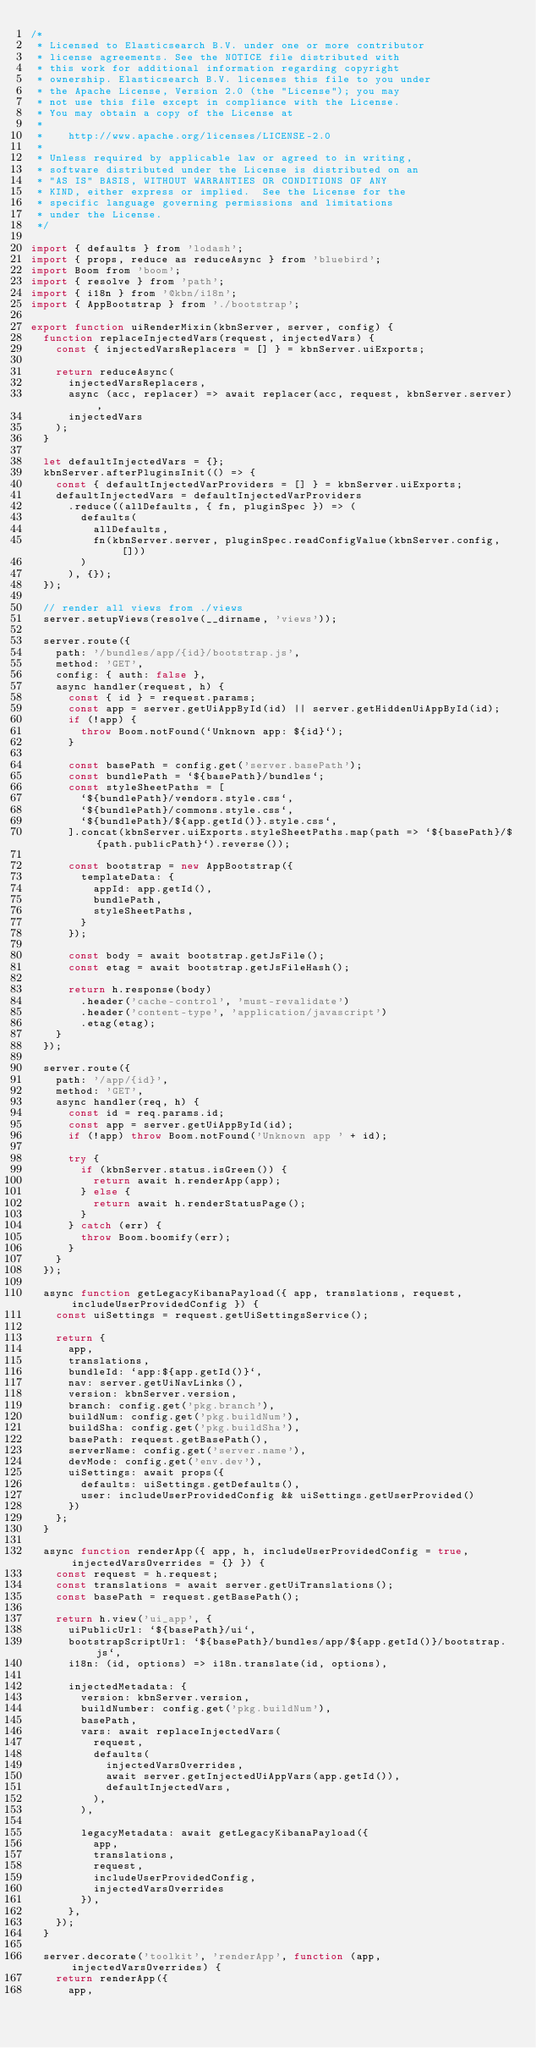Convert code to text. <code><loc_0><loc_0><loc_500><loc_500><_JavaScript_>/*
 * Licensed to Elasticsearch B.V. under one or more contributor
 * license agreements. See the NOTICE file distributed with
 * this work for additional information regarding copyright
 * ownership. Elasticsearch B.V. licenses this file to you under
 * the Apache License, Version 2.0 (the "License"); you may
 * not use this file except in compliance with the License.
 * You may obtain a copy of the License at
 *
 *    http://www.apache.org/licenses/LICENSE-2.0
 *
 * Unless required by applicable law or agreed to in writing,
 * software distributed under the License is distributed on an
 * "AS IS" BASIS, WITHOUT WARRANTIES OR CONDITIONS OF ANY
 * KIND, either express or implied.  See the License for the
 * specific language governing permissions and limitations
 * under the License.
 */

import { defaults } from 'lodash';
import { props, reduce as reduceAsync } from 'bluebird';
import Boom from 'boom';
import { resolve } from 'path';
import { i18n } from '@kbn/i18n';
import { AppBootstrap } from './bootstrap';

export function uiRenderMixin(kbnServer, server, config) {
  function replaceInjectedVars(request, injectedVars) {
    const { injectedVarsReplacers = [] } = kbnServer.uiExports;

    return reduceAsync(
      injectedVarsReplacers,
      async (acc, replacer) => await replacer(acc, request, kbnServer.server),
      injectedVars
    );
  }

  let defaultInjectedVars = {};
  kbnServer.afterPluginsInit(() => {
    const { defaultInjectedVarProviders = [] } = kbnServer.uiExports;
    defaultInjectedVars = defaultInjectedVarProviders
      .reduce((allDefaults, { fn, pluginSpec }) => (
        defaults(
          allDefaults,
          fn(kbnServer.server, pluginSpec.readConfigValue(kbnServer.config, []))
        )
      ), {});
  });

  // render all views from ./views
  server.setupViews(resolve(__dirname, 'views'));

  server.route({
    path: '/bundles/app/{id}/bootstrap.js',
    method: 'GET',
    config: { auth: false },
    async handler(request, h) {
      const { id } = request.params;
      const app = server.getUiAppById(id) || server.getHiddenUiAppById(id);
      if (!app) {
        throw Boom.notFound(`Unknown app: ${id}`);
      }

      const basePath = config.get('server.basePath');
      const bundlePath = `${basePath}/bundles`;
      const styleSheetPaths = [
        `${bundlePath}/vendors.style.css`,
        `${bundlePath}/commons.style.css`,
        `${bundlePath}/${app.getId()}.style.css`,
      ].concat(kbnServer.uiExports.styleSheetPaths.map(path => `${basePath}/${path.publicPath}`).reverse());

      const bootstrap = new AppBootstrap({
        templateData: {
          appId: app.getId(),
          bundlePath,
          styleSheetPaths,
        }
      });

      const body = await bootstrap.getJsFile();
      const etag = await bootstrap.getJsFileHash();

      return h.response(body)
        .header('cache-control', 'must-revalidate')
        .header('content-type', 'application/javascript')
        .etag(etag);
    }
  });

  server.route({
    path: '/app/{id}',
    method: 'GET',
    async handler(req, h) {
      const id = req.params.id;
      const app = server.getUiAppById(id);
      if (!app) throw Boom.notFound('Unknown app ' + id);

      try {
        if (kbnServer.status.isGreen()) {
          return await h.renderApp(app);
        } else {
          return await h.renderStatusPage();
        }
      } catch (err) {
        throw Boom.boomify(err);
      }
    }
  });

  async function getLegacyKibanaPayload({ app, translations, request, includeUserProvidedConfig }) {
    const uiSettings = request.getUiSettingsService();

    return {
      app,
      translations,
      bundleId: `app:${app.getId()}`,
      nav: server.getUiNavLinks(),
      version: kbnServer.version,
      branch: config.get('pkg.branch'),
      buildNum: config.get('pkg.buildNum'),
      buildSha: config.get('pkg.buildSha'),
      basePath: request.getBasePath(),
      serverName: config.get('server.name'),
      devMode: config.get('env.dev'),
      uiSettings: await props({
        defaults: uiSettings.getDefaults(),
        user: includeUserProvidedConfig && uiSettings.getUserProvided()
      })
    };
  }

  async function renderApp({ app, h, includeUserProvidedConfig = true, injectedVarsOverrides = {} }) {
    const request = h.request;
    const translations = await server.getUiTranslations();
    const basePath = request.getBasePath();

    return h.view('ui_app', {
      uiPublicUrl: `${basePath}/ui`,
      bootstrapScriptUrl: `${basePath}/bundles/app/${app.getId()}/bootstrap.js`,
      i18n: (id, options) => i18n.translate(id, options),

      injectedMetadata: {
        version: kbnServer.version,
        buildNumber: config.get('pkg.buildNum'),
        basePath,
        vars: await replaceInjectedVars(
          request,
          defaults(
            injectedVarsOverrides,
            await server.getInjectedUiAppVars(app.getId()),
            defaultInjectedVars,
          ),
        ),

        legacyMetadata: await getLegacyKibanaPayload({
          app,
          translations,
          request,
          includeUserProvidedConfig,
          injectedVarsOverrides
        }),
      },
    });
  }

  server.decorate('toolkit', 'renderApp', function (app, injectedVarsOverrides) {
    return renderApp({
      app,</code> 